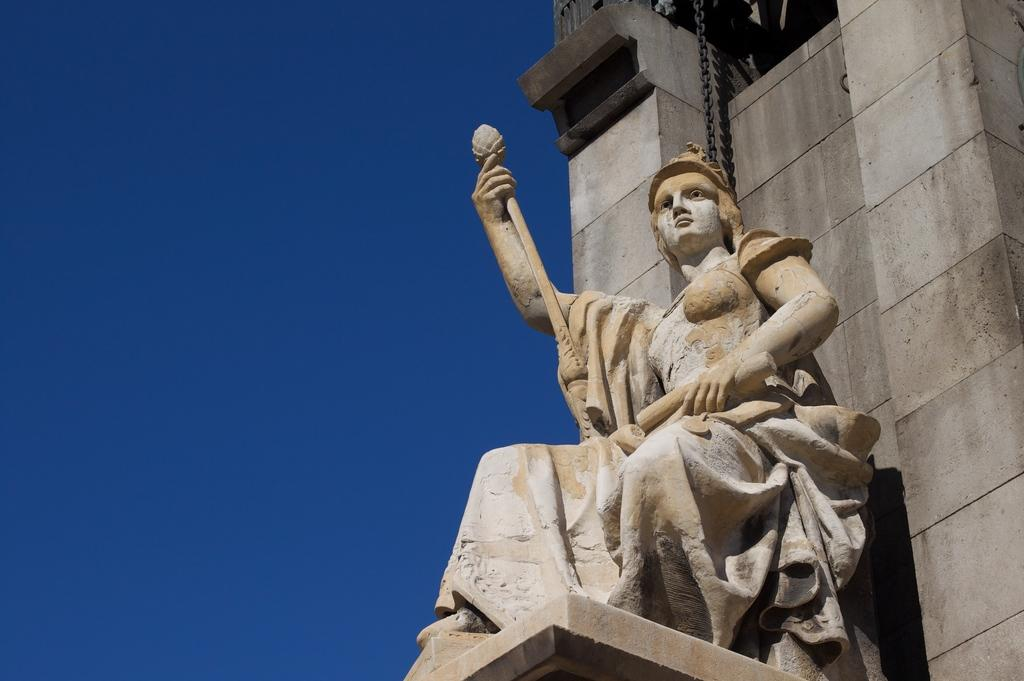What is the main subject in the image? There is a statue in the image. Can you describe the building in the background? The building in the background has brown and cream colors. What color is the sky in the image? The sky is blue in the image. What type of net can be seen surrounding the statue in the image? There is no net surrounding the statue in the image. How many matches are visible in the image? There are no matches present in the image. 